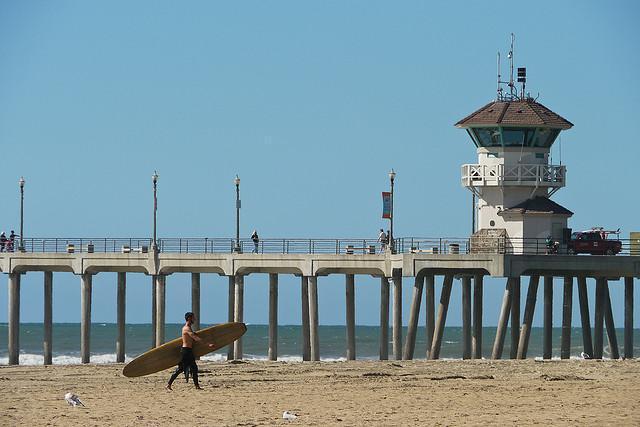How many birds are on the beach?
Give a very brief answer. 2. 